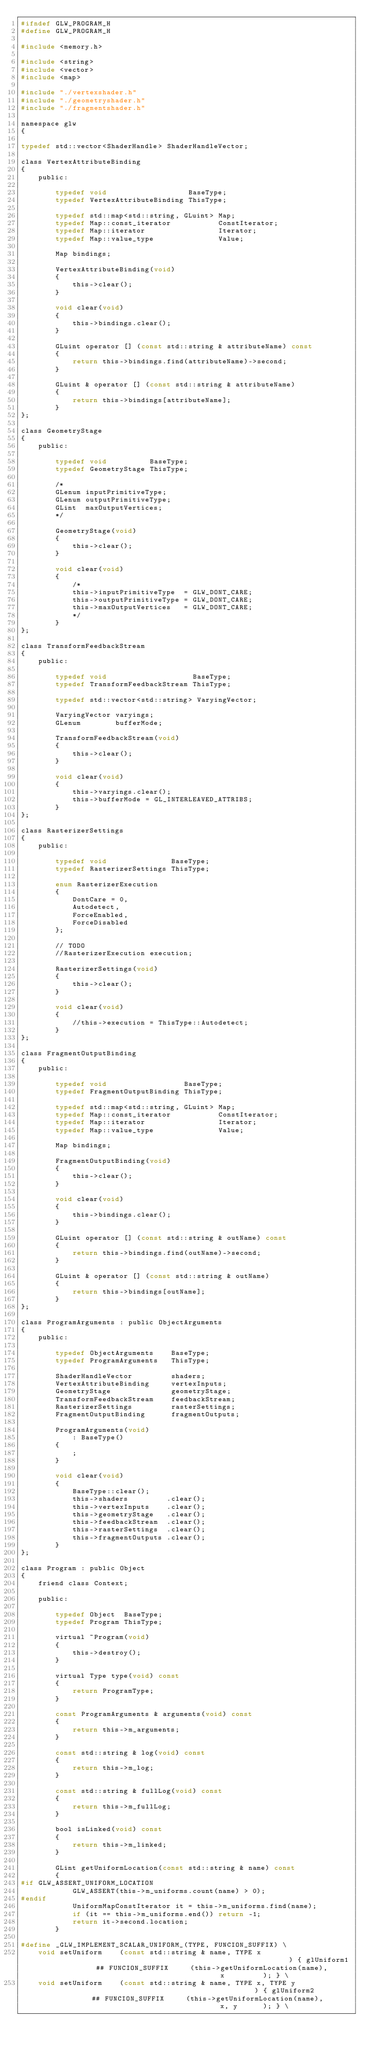Convert code to text. <code><loc_0><loc_0><loc_500><loc_500><_C_>#ifndef GLW_PROGRAM_H
#define GLW_PROGRAM_H

#include <memory.h>

#include <string>
#include <vector>
#include <map>

#include "./vertexshader.h"
#include "./geometryshader.h"
#include "./fragmentshader.h"

namespace glw
{

typedef std::vector<ShaderHandle> ShaderHandleVector;

class VertexAttributeBinding
{
    public:

        typedef void                   BaseType;
        typedef VertexAttributeBinding ThisType;

        typedef std::map<std::string, GLuint> Map;
        typedef Map::const_iterator           ConstIterator;
        typedef Map::iterator                 Iterator;
        typedef Map::value_type               Value;

        Map bindings;

        VertexAttributeBinding(void)
        {
            this->clear();
        }

        void clear(void)
        {
            this->bindings.clear();
        }

        GLuint operator [] (const std::string & attributeName) const
        {
            return this->bindings.find(attributeName)->second;
        }

        GLuint & operator [] (const std::string & attributeName)
        {
            return this->bindings[attributeName];
        }
};

class GeometryStage
{
    public:

        typedef void          BaseType;
        typedef GeometryStage ThisType;

        /*
        GLenum inputPrimitiveType;
        GLenum outputPrimitiveType;
        GLint  maxOutputVertices;
        */

        GeometryStage(void)
        {
            this->clear();
        }

        void clear(void)
        {
            /*
            this->inputPrimitiveType  = GLW_DONT_CARE;
            this->outputPrimitiveType = GLW_DONT_CARE;
            this->maxOutputVertices   = GLW_DONT_CARE;
            */
        }
};

class TransformFeedbackStream
{
    public:

        typedef void                    BaseType;
        typedef TransformFeedbackStream ThisType;

        typedef std::vector<std::string> VaryingVector;

        VaryingVector varyings;
        GLenum        bufferMode;

        TransformFeedbackStream(void)
        {
            this->clear();
        }

        void clear(void)
        {
            this->varyings.clear();
            this->bufferMode = GL_INTERLEAVED_ATTRIBS;
        }
};

class RasterizerSettings
{
    public:

        typedef void               BaseType;
        typedef RasterizerSettings ThisType;

        enum RasterizerExecution
        {
            DontCare = 0,
            Autodetect,
            ForceEnabled,
            ForceDisabled
        };

        // TODO
        //RasterizerExecution execution;

        RasterizerSettings(void)
        {
            this->clear();
        }

        void clear(void)
        {
            //this->execution = ThisType::Autodetect;
        }
};

class FragmentOutputBinding
{
    public:

        typedef void                  BaseType;
        typedef FragmentOutputBinding ThisType;

        typedef std::map<std::string, GLuint> Map;
        typedef Map::const_iterator           ConstIterator;
        typedef Map::iterator                 Iterator;
        typedef Map::value_type               Value;

        Map bindings;

        FragmentOutputBinding(void)
        {
            this->clear();
        }

        void clear(void)
        {
            this->bindings.clear();
        }

        GLuint operator [] (const std::string & outName) const
        {
            return this->bindings.find(outName)->second;
        }

        GLuint & operator [] (const std::string & outName)
        {
            return this->bindings[outName];
        }
};

class ProgramArguments : public ObjectArguments
{
    public:

        typedef ObjectArguments    BaseType;
        typedef ProgramArguments   ThisType;

        ShaderHandleVector         shaders;
        VertexAttributeBinding     vertexInputs;
        GeometryStage              geometryStage;
        TransformFeedbackStream    feedbackStream;
        RasterizerSettings         rasterSettings;
        FragmentOutputBinding      fragmentOutputs;

        ProgramArguments(void)
            : BaseType()
        {
            ;
        }

        void clear(void)
        {
            BaseType::clear();
            this->shaders         .clear();
            this->vertexInputs    .clear();
            this->geometryStage   .clear();
            this->feedbackStream  .clear();
            this->rasterSettings  .clear();
            this->fragmentOutputs .clear();
        }
};

class Program : public Object
{
    friend class Context;

    public:

        typedef Object  BaseType;
        typedef Program ThisType;

        virtual ~Program(void)
        {
            this->destroy();
        }

        virtual Type type(void) const
        {
            return ProgramType;
        }

        const ProgramArguments & arguments(void) const
        {
            return this->m_arguments;
        }

        const std::string & log(void) const
        {
            return this->m_log;
        }

        const std::string & fullLog(void) const
        {
            return this->m_fullLog;
        }

        bool isLinked(void) const
        {
            return this->m_linked;
        }

        GLint getUniformLocation(const std::string & name) const
        {
#if GLW_ASSERT_UNIFORM_LOCATION
            GLW_ASSERT(this->m_uniforms.count(name) > 0);
#endif
            UniformMapConstIterator it = this->m_uniforms.find(name);
            if (it == this->m_uniforms.end()) return -1;
            return it->second.location;
        }

#define _GLW_IMPLEMENT_SCALAR_UNIFORM_(TYPE, FUNCION_SUFFIX) \
    void setUniform    (const std::string & name, TYPE x                                                       ) { glUniform1         ## FUNCION_SUFFIX     (this->getUniformLocation(name),                                       x         ); } \
    void setUniform    (const std::string & name, TYPE x, TYPE y                                               ) { glUniform2         ## FUNCION_SUFFIX     (this->getUniformLocation(name),                                       x, y      ); } \</code> 